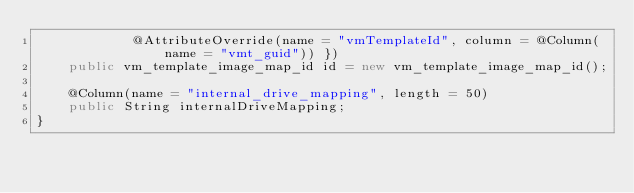<code> <loc_0><loc_0><loc_500><loc_500><_Java_>            @AttributeOverride(name = "vmTemplateId", column = @Column(name = "vmt_guid")) })
    public vm_template_image_map_id id = new vm_template_image_map_id();

    @Column(name = "internal_drive_mapping", length = 50)
    public String internalDriveMapping;
}
</code> 